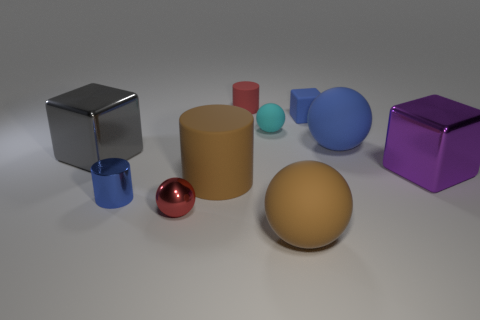Does the metallic block to the right of the small red cylinder have the same color as the matte cube?
Keep it short and to the point. No. How many other objects are there of the same size as the blue cylinder?
Provide a succinct answer. 4. Do the blue block and the big gray cube have the same material?
Provide a succinct answer. No. What is the color of the large metal thing that is to the left of the small thing to the right of the large brown rubber ball?
Your response must be concise. Gray. What is the size of the purple object that is the same shape as the large gray object?
Your response must be concise. Large. Do the small metallic cylinder and the small matte ball have the same color?
Provide a short and direct response. No. What number of big matte spheres are in front of the big metallic cube to the left of the large rubber sphere that is behind the large brown sphere?
Ensure brevity in your answer.  1. Is the number of large blue matte things greater than the number of small brown shiny objects?
Give a very brief answer. Yes. What number of tiny blue cubes are there?
Offer a very short reply. 1. There is a blue metallic object right of the large metallic object behind the large block that is right of the large brown ball; what is its shape?
Ensure brevity in your answer.  Cylinder. 